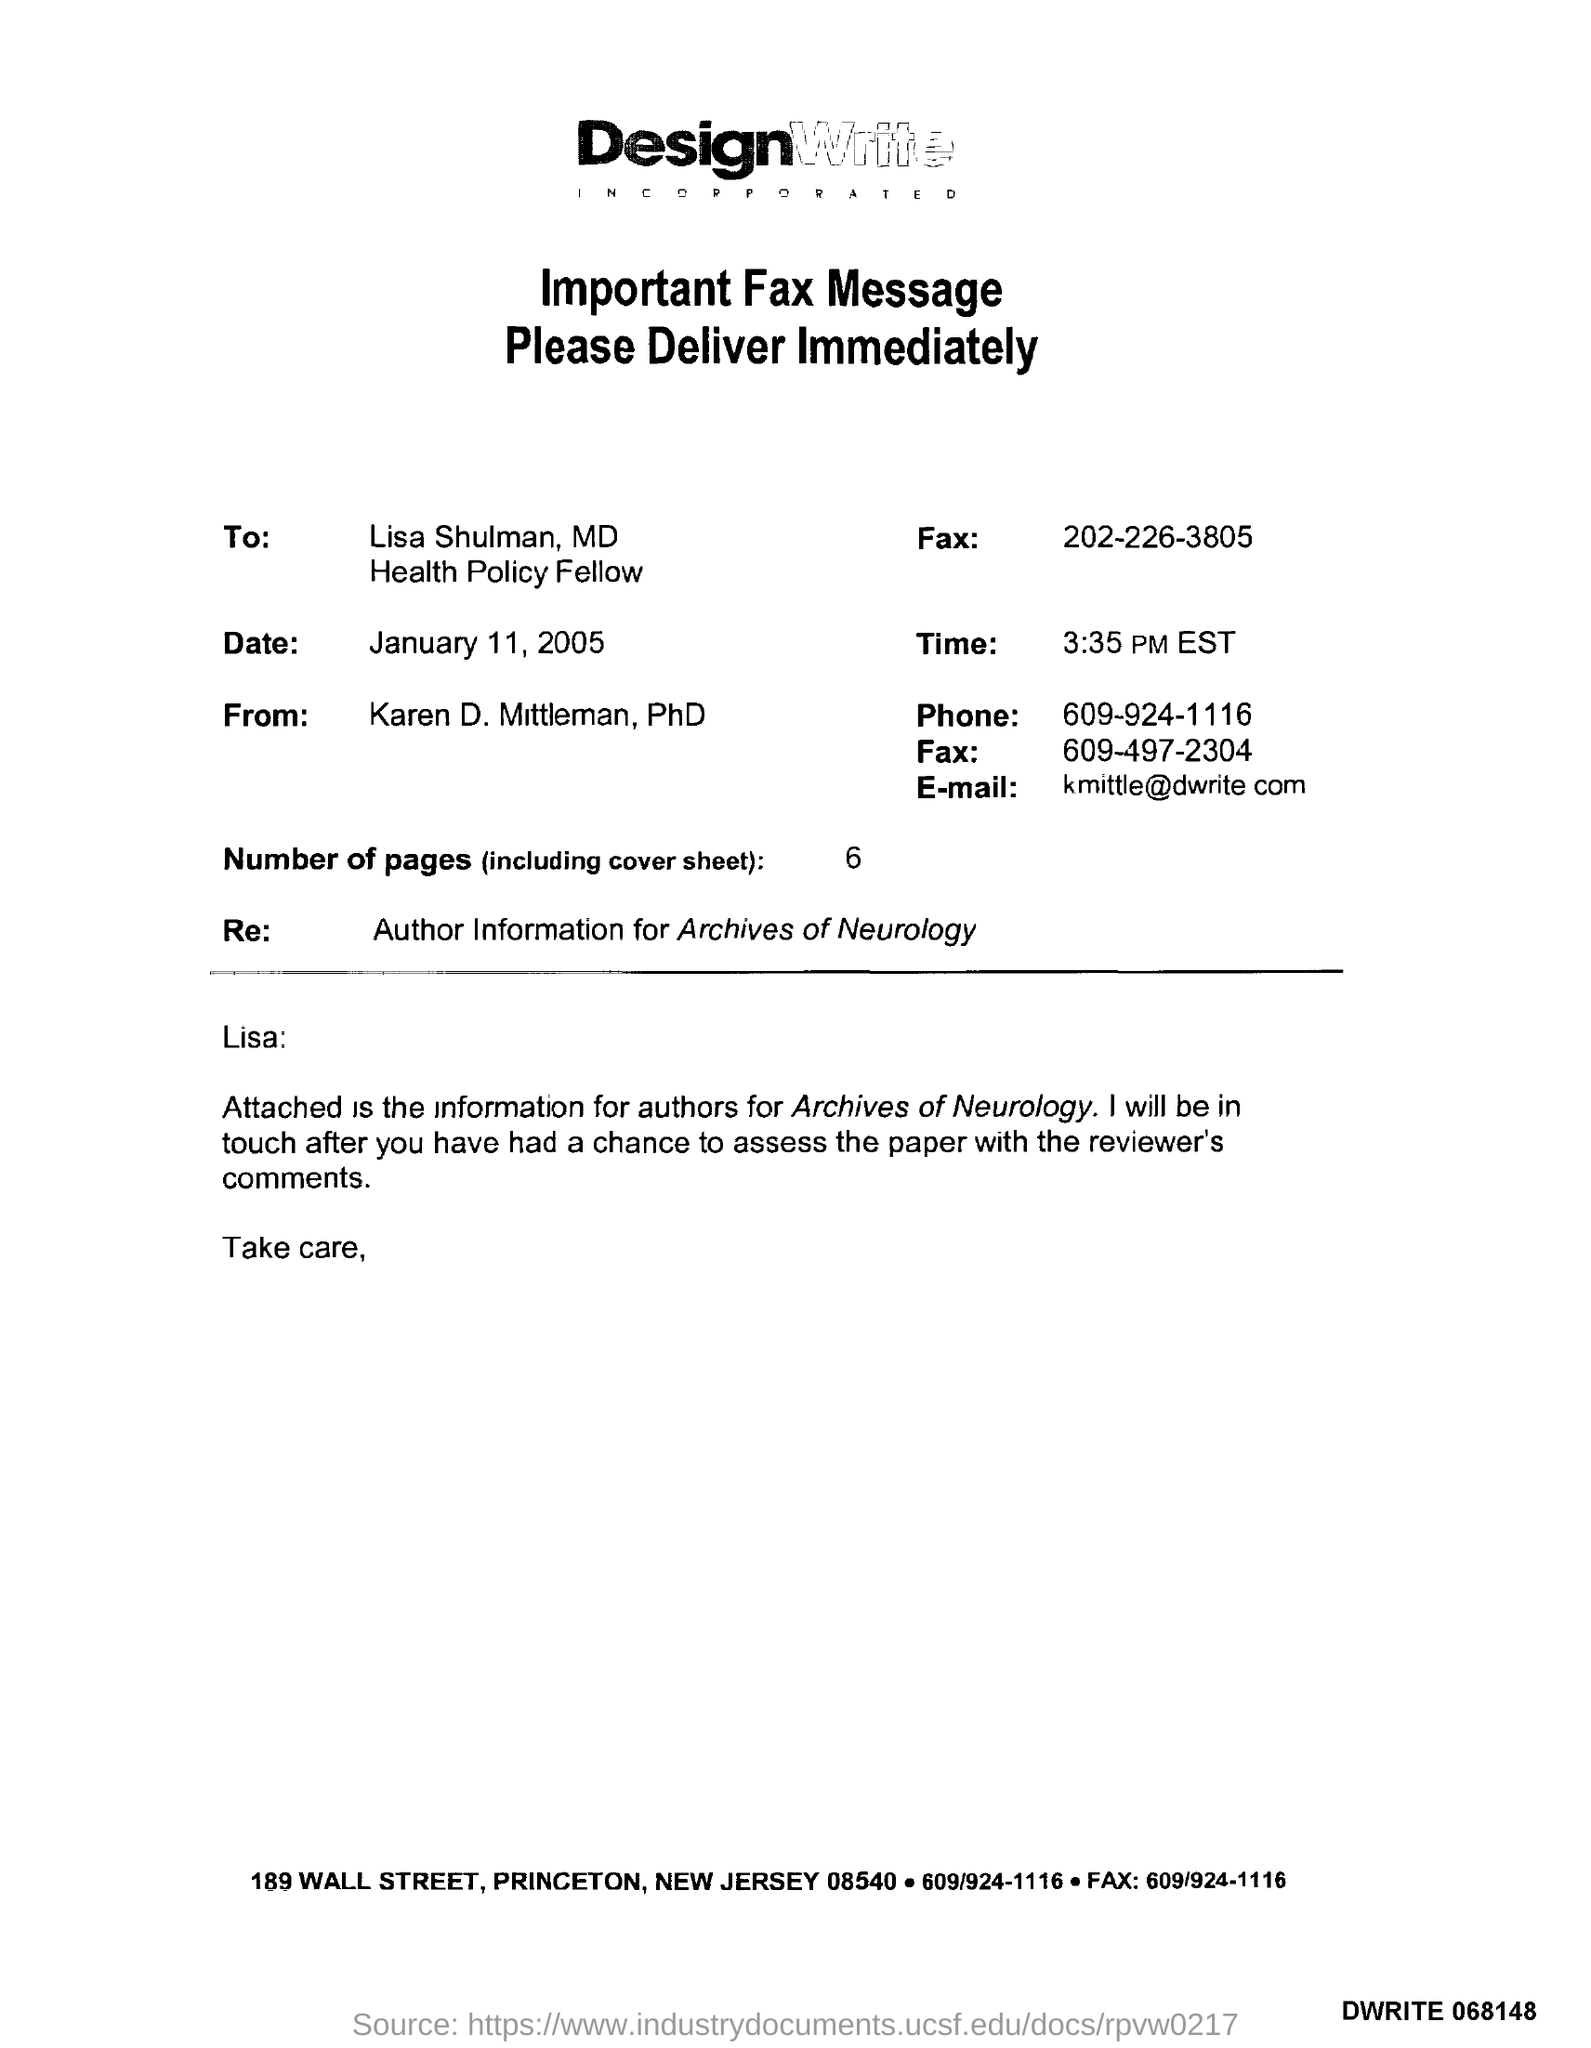Identify some key points in this picture. There are six pages in total. The sender's fax number is 609-497-2304. The date mentioned in this document is January 11, 2005. The memorandum is addressed to Lisa Shulman. The receiver's fax number is 202-226-3805. 